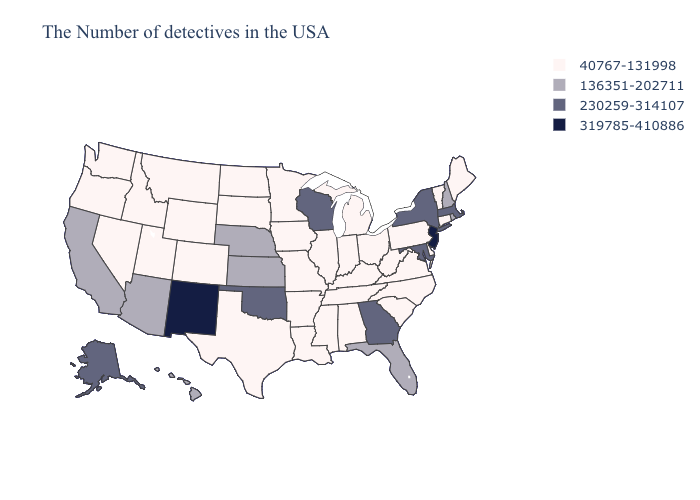Does Alabama have a higher value than Idaho?
Concise answer only. No. Among the states that border Indiana , which have the highest value?
Quick response, please. Ohio, Michigan, Kentucky, Illinois. Does New Mexico have the lowest value in the USA?
Be succinct. No. What is the value of New Jersey?
Quick response, please. 319785-410886. Which states have the lowest value in the USA?
Write a very short answer. Maine, Vermont, Connecticut, Delaware, Pennsylvania, Virginia, North Carolina, South Carolina, West Virginia, Ohio, Michigan, Kentucky, Indiana, Alabama, Tennessee, Illinois, Mississippi, Louisiana, Missouri, Arkansas, Minnesota, Iowa, Texas, South Dakota, North Dakota, Wyoming, Colorado, Utah, Montana, Idaho, Nevada, Washington, Oregon. Is the legend a continuous bar?
Concise answer only. No. What is the value of Iowa?
Quick response, please. 40767-131998. What is the highest value in states that border Utah?
Concise answer only. 319785-410886. What is the value of Nebraska?
Concise answer only. 136351-202711. What is the value of North Carolina?
Concise answer only. 40767-131998. Does the first symbol in the legend represent the smallest category?
Write a very short answer. Yes. Name the states that have a value in the range 136351-202711?
Write a very short answer. Rhode Island, New Hampshire, Florida, Kansas, Nebraska, Arizona, California, Hawaii. What is the highest value in the South ?
Concise answer only. 230259-314107. Which states have the highest value in the USA?
Concise answer only. New Jersey, New Mexico. Does the first symbol in the legend represent the smallest category?
Concise answer only. Yes. 